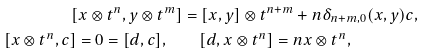<formula> <loc_0><loc_0><loc_500><loc_500>[ x \otimes t ^ { n } , y \otimes t ^ { m } ] & = [ x , y ] \otimes t ^ { n + m } + n \delta _ { n + m , 0 } ( x , y ) c , \\ [ x \otimes t ^ { n } , c ] = 0 = [ d , c ] , \quad & \quad [ d , x \otimes t ^ { n } ] = n x \otimes t ^ { n } ,</formula> 